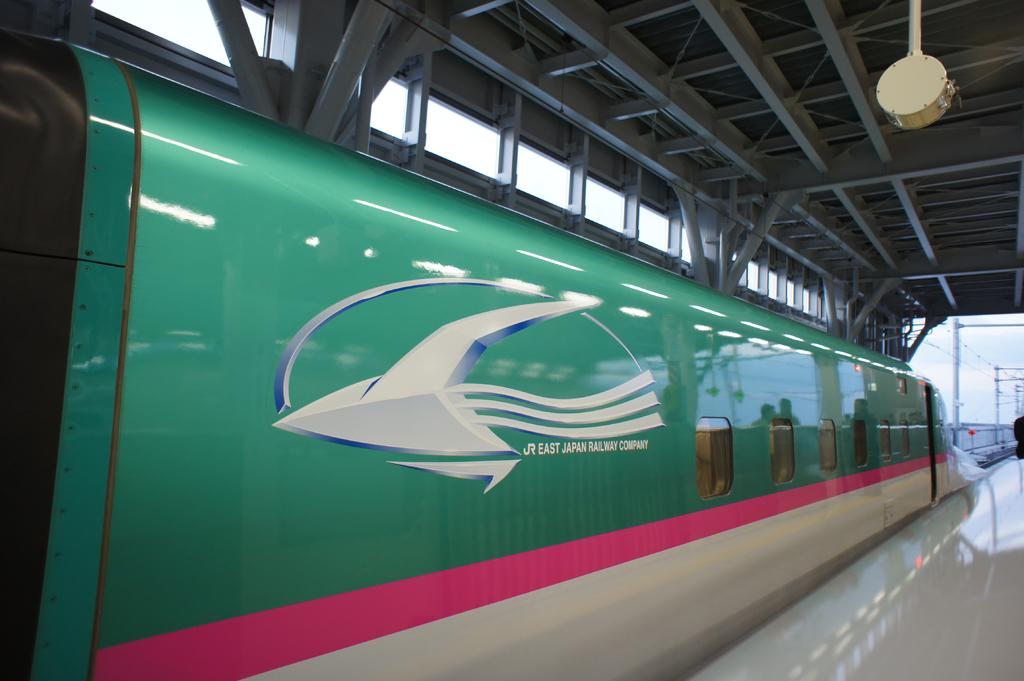What is the main subject of the image? The main subject of the image is a train. Where is the train located in the image? The train is on a track. What type of material is visible at the top of the image? There is a metal ceiling visible at the top of the image. What color is the dress worn by the train conductor in the image? There is no train conductor or dress present in the image. Is there a river visible in the image? No, there is no river visible in the image; it features a train on a track with a metal ceiling. 